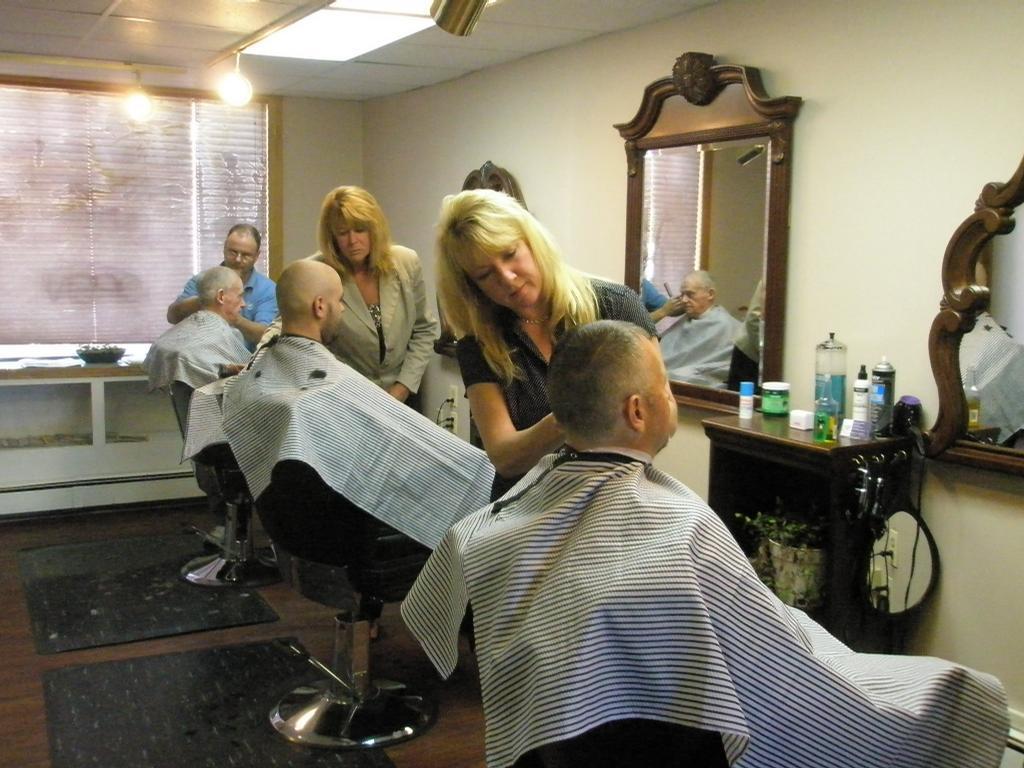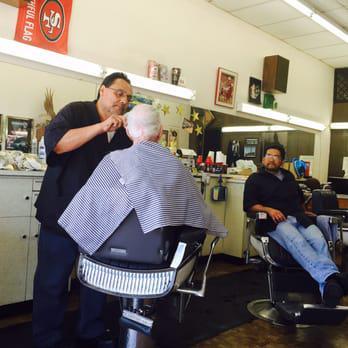The first image is the image on the left, the second image is the image on the right. Examine the images to the left and right. Is the description "There is at least one male barber in a black shirt cutting the hair of a man in a cape sitting in the barber chair." accurate? Answer yes or no. Yes. 